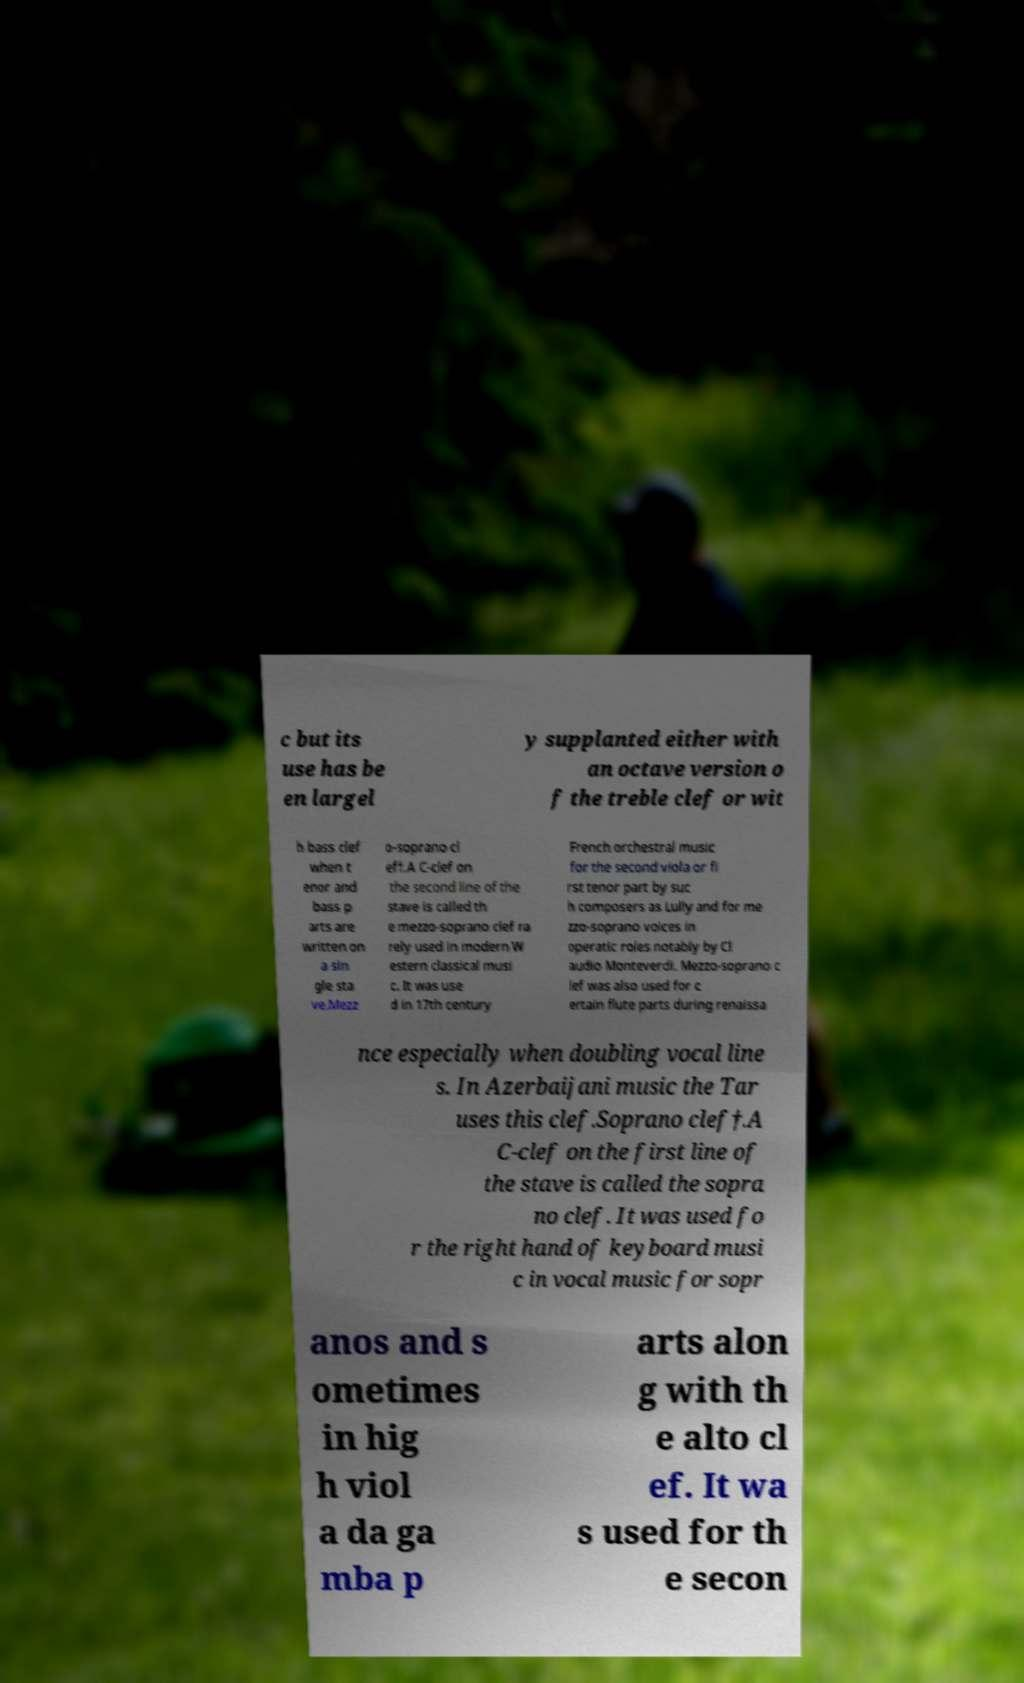There's text embedded in this image that I need extracted. Can you transcribe it verbatim? c but its use has be en largel y supplanted either with an octave version o f the treble clef or wit h bass clef when t enor and bass p arts are written on a sin gle sta ve.Mezz o-soprano cl ef†.A C-clef on the second line of the stave is called th e mezzo-soprano clef ra rely used in modern W estern classical musi c. It was use d in 17th century French orchestral music for the second viola or fi rst tenor part by suc h composers as Lully and for me zzo-soprano voices in operatic roles notably by Cl audio Monteverdi. Mezzo-soprano c lef was also used for c ertain flute parts during renaissa nce especially when doubling vocal line s. In Azerbaijani music the Tar uses this clef.Soprano clef†.A C-clef on the first line of the stave is called the sopra no clef. It was used fo r the right hand of keyboard musi c in vocal music for sopr anos and s ometimes in hig h viol a da ga mba p arts alon g with th e alto cl ef. It wa s used for th e secon 